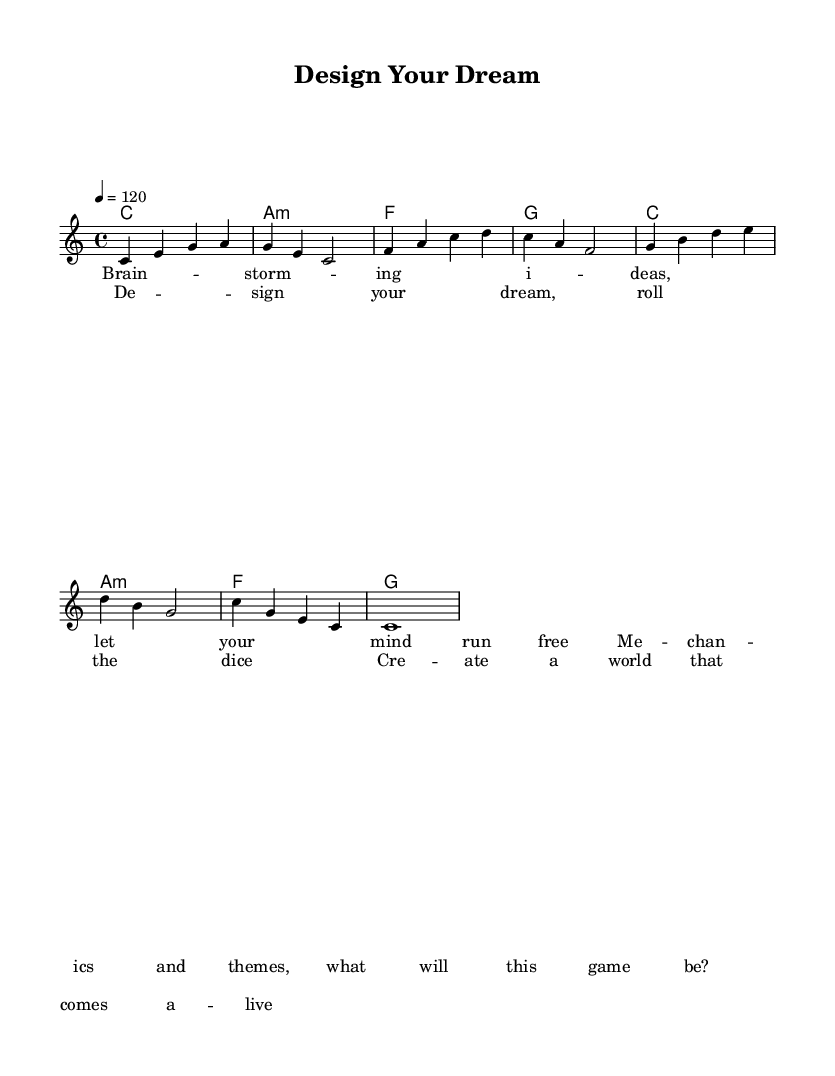What is the time signature of this music? The time signature is indicated at the beginning of the score, which shows 4/4. This means there are 4 beats in each measure and the quarter note receives one beat.
Answer: 4/4 What is the key signature of this music? The key signature is C major, as indicated in the score. It has no sharps or flats, which is characteristic of the C major scale.
Answer: C major What is the tempo marking of the piece? The tempo marking is found in the global section, which states the tempo as 4 = 120. This means there should be 120 beats per minute, with a quarter note getting one beat.
Answer: 120 How many measures are there in the melody? To find the number of measures, we count the individual segments of the melody line, each divided by vertical lines. There are a total of 8 measures in the melody section provided.
Answer: 8 What is the first word of the chorus lyrics? The chorus lyrics start with "Design," which is the first word following the cue for the chorus in the lyric section.
Answer: Design How many different chords are used in the harmonies section? The harmonies section includes four different chord symbols: C, A minor, F, and G. By counting the unique chords listed, we find there are 4 distinct chords.
Answer: 4 What is the last note of the melody? The last note in the melody, as indicated at the end of the melody section, is a whole note C, which fills the final measure.
Answer: C 